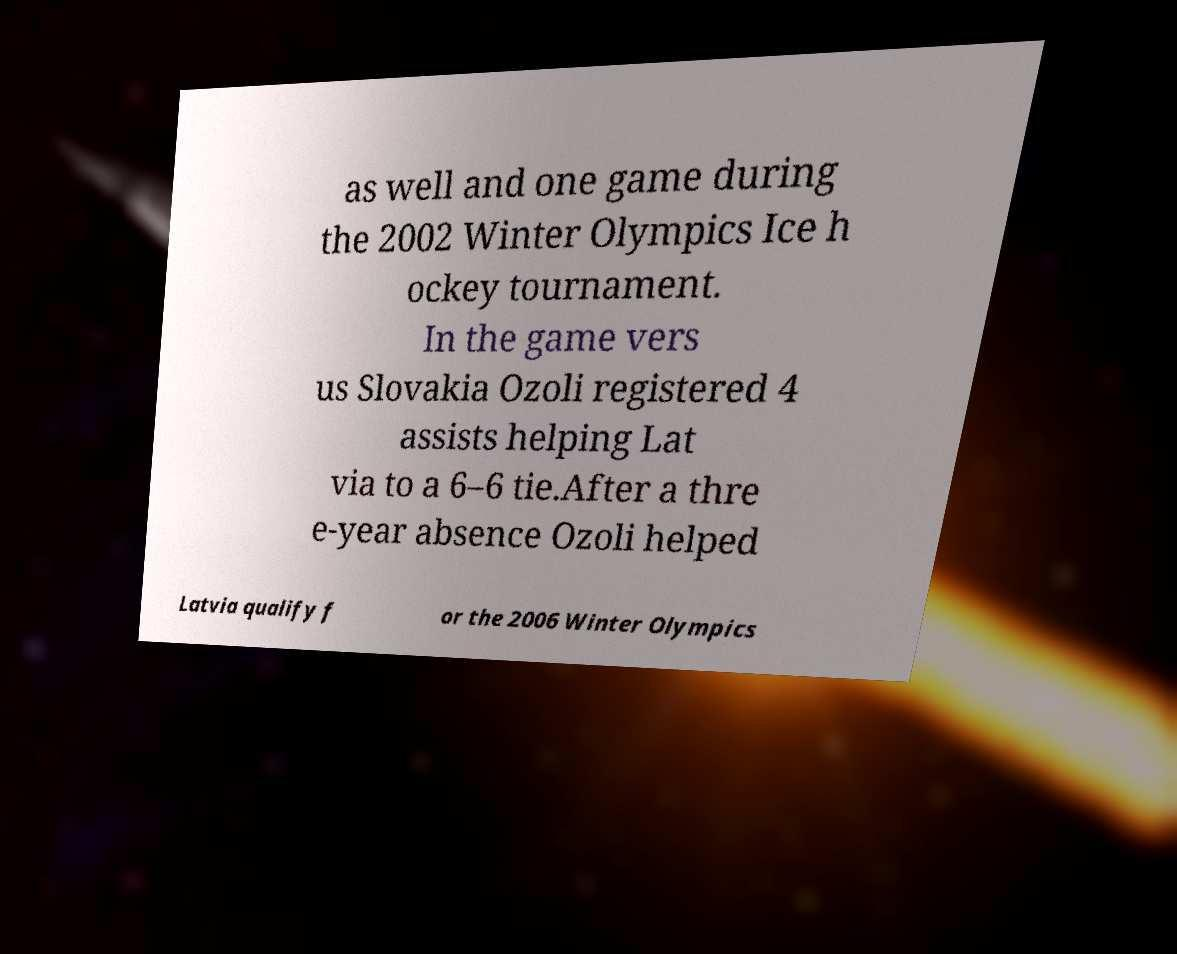Please identify and transcribe the text found in this image. as well and one game during the 2002 Winter Olympics Ice h ockey tournament. In the game vers us Slovakia Ozoli registered 4 assists helping Lat via to a 6–6 tie.After a thre e-year absence Ozoli helped Latvia qualify f or the 2006 Winter Olympics 